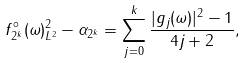Convert formula to latex. <formula><loc_0><loc_0><loc_500><loc_500>\| f _ { 2 ^ { k } } ^ { \circ } ( \omega ) \| _ { L ^ { 2 } } ^ { 2 } - \alpha _ { 2 ^ { k } } = \sum _ { j = 0 } ^ { k } \frac { | g _ { j } ( \omega ) | ^ { 2 } - 1 } { 4 j + 2 } ,</formula> 